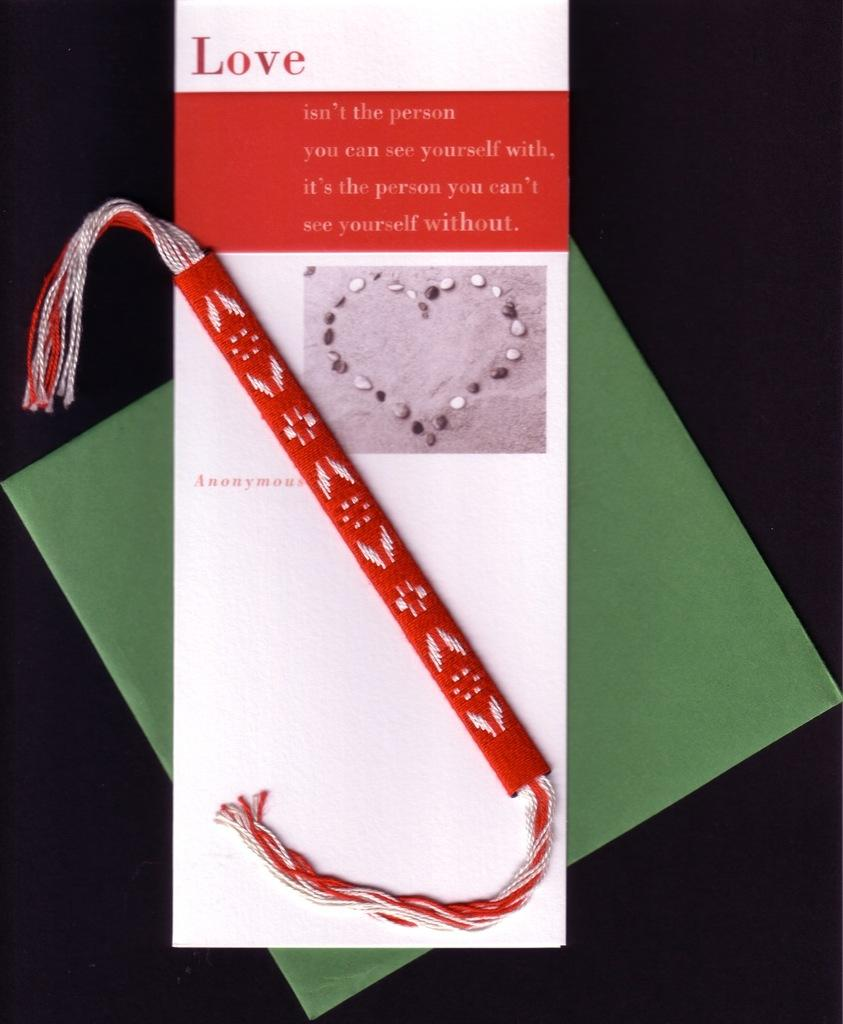<image>
Present a compact description of the photo's key features. A card with the headline Love rests on top of a green envelop. 